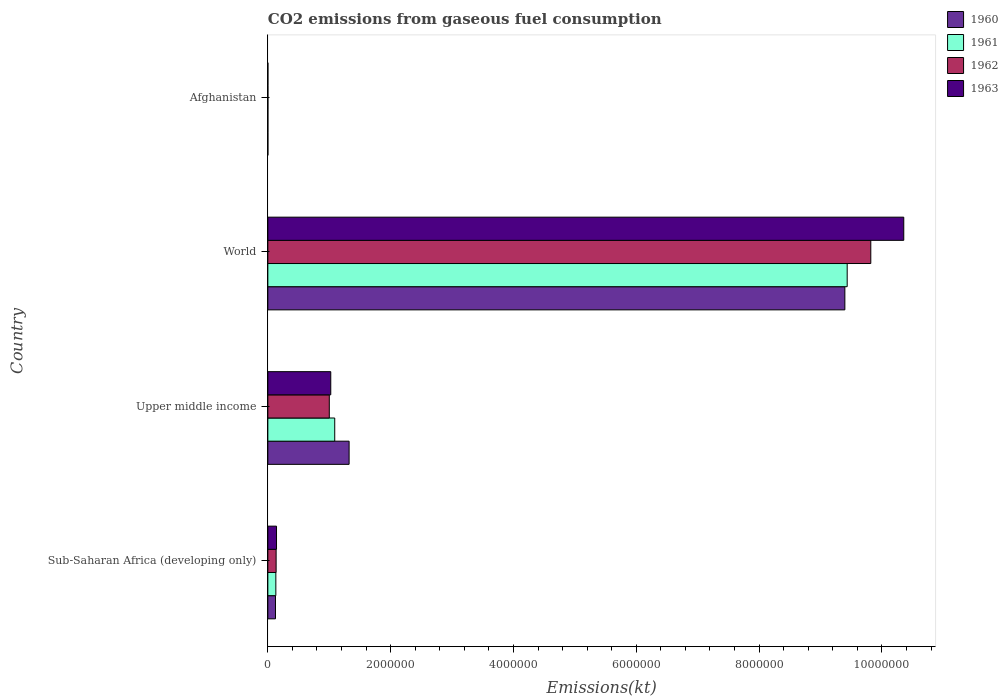How many different coloured bars are there?
Keep it short and to the point. 4. How many groups of bars are there?
Your answer should be compact. 4. Are the number of bars per tick equal to the number of legend labels?
Ensure brevity in your answer.  Yes. What is the label of the 3rd group of bars from the top?
Give a very brief answer. Upper middle income. What is the amount of CO2 emitted in 1960 in Sub-Saharan Africa (developing only)?
Your answer should be very brief. 1.24e+05. Across all countries, what is the maximum amount of CO2 emitted in 1961?
Offer a terse response. 9.43e+06. Across all countries, what is the minimum amount of CO2 emitted in 1962?
Keep it short and to the point. 689.4. In which country was the amount of CO2 emitted in 1961 minimum?
Your response must be concise. Afghanistan. What is the total amount of CO2 emitted in 1960 in the graph?
Your response must be concise. 1.08e+07. What is the difference between the amount of CO2 emitted in 1962 in Sub-Saharan Africa (developing only) and that in World?
Your answer should be very brief. -9.68e+06. What is the difference between the amount of CO2 emitted in 1961 in Afghanistan and the amount of CO2 emitted in 1960 in Upper middle income?
Your answer should be compact. -1.32e+06. What is the average amount of CO2 emitted in 1963 per country?
Your answer should be very brief. 2.88e+06. What is the difference between the amount of CO2 emitted in 1961 and amount of CO2 emitted in 1960 in Upper middle income?
Your response must be concise. -2.34e+05. In how many countries, is the amount of CO2 emitted in 1962 greater than 2000000 kt?
Give a very brief answer. 1. What is the ratio of the amount of CO2 emitted in 1961 in Sub-Saharan Africa (developing only) to that in World?
Keep it short and to the point. 0.01. What is the difference between the highest and the second highest amount of CO2 emitted in 1961?
Make the answer very short. 8.35e+06. What is the difference between the highest and the lowest amount of CO2 emitted in 1963?
Your answer should be very brief. 1.04e+07. What does the 2nd bar from the bottom in Upper middle income represents?
Offer a terse response. 1961. Are the values on the major ticks of X-axis written in scientific E-notation?
Your response must be concise. No. Does the graph contain grids?
Give a very brief answer. No. Where does the legend appear in the graph?
Keep it short and to the point. Top right. What is the title of the graph?
Your answer should be very brief. CO2 emissions from gaseous fuel consumption. Does "2015" appear as one of the legend labels in the graph?
Provide a succinct answer. No. What is the label or title of the X-axis?
Provide a succinct answer. Emissions(kt). What is the label or title of the Y-axis?
Give a very brief answer. Country. What is the Emissions(kt) of 1960 in Sub-Saharan Africa (developing only)?
Ensure brevity in your answer.  1.24e+05. What is the Emissions(kt) of 1961 in Sub-Saharan Africa (developing only)?
Offer a terse response. 1.30e+05. What is the Emissions(kt) in 1962 in Sub-Saharan Africa (developing only)?
Give a very brief answer. 1.35e+05. What is the Emissions(kt) in 1963 in Sub-Saharan Africa (developing only)?
Offer a terse response. 1.41e+05. What is the Emissions(kt) in 1960 in Upper middle income?
Your answer should be very brief. 1.32e+06. What is the Emissions(kt) in 1961 in Upper middle income?
Offer a very short reply. 1.09e+06. What is the Emissions(kt) of 1962 in Upper middle income?
Offer a terse response. 1.00e+06. What is the Emissions(kt) in 1963 in Upper middle income?
Give a very brief answer. 1.02e+06. What is the Emissions(kt) in 1960 in World?
Your response must be concise. 9.40e+06. What is the Emissions(kt) of 1961 in World?
Keep it short and to the point. 9.43e+06. What is the Emissions(kt) of 1962 in World?
Provide a short and direct response. 9.82e+06. What is the Emissions(kt) of 1963 in World?
Provide a succinct answer. 1.04e+07. What is the Emissions(kt) of 1960 in Afghanistan?
Provide a succinct answer. 414.37. What is the Emissions(kt) in 1961 in Afghanistan?
Provide a succinct answer. 491.38. What is the Emissions(kt) in 1962 in Afghanistan?
Your answer should be compact. 689.4. What is the Emissions(kt) of 1963 in Afghanistan?
Keep it short and to the point. 707.73. Across all countries, what is the maximum Emissions(kt) in 1960?
Make the answer very short. 9.40e+06. Across all countries, what is the maximum Emissions(kt) of 1961?
Offer a terse response. 9.43e+06. Across all countries, what is the maximum Emissions(kt) in 1962?
Offer a terse response. 9.82e+06. Across all countries, what is the maximum Emissions(kt) of 1963?
Ensure brevity in your answer.  1.04e+07. Across all countries, what is the minimum Emissions(kt) of 1960?
Offer a terse response. 414.37. Across all countries, what is the minimum Emissions(kt) of 1961?
Keep it short and to the point. 491.38. Across all countries, what is the minimum Emissions(kt) of 1962?
Your answer should be compact. 689.4. Across all countries, what is the minimum Emissions(kt) in 1963?
Ensure brevity in your answer.  707.73. What is the total Emissions(kt) of 1960 in the graph?
Your answer should be very brief. 1.08e+07. What is the total Emissions(kt) in 1961 in the graph?
Provide a short and direct response. 1.07e+07. What is the total Emissions(kt) in 1962 in the graph?
Your response must be concise. 1.10e+07. What is the total Emissions(kt) in 1963 in the graph?
Provide a short and direct response. 1.15e+07. What is the difference between the Emissions(kt) in 1960 in Sub-Saharan Africa (developing only) and that in Upper middle income?
Ensure brevity in your answer.  -1.20e+06. What is the difference between the Emissions(kt) of 1961 in Sub-Saharan Africa (developing only) and that in Upper middle income?
Offer a terse response. -9.59e+05. What is the difference between the Emissions(kt) of 1962 in Sub-Saharan Africa (developing only) and that in Upper middle income?
Your response must be concise. -8.66e+05. What is the difference between the Emissions(kt) of 1963 in Sub-Saharan Africa (developing only) and that in Upper middle income?
Ensure brevity in your answer.  -8.83e+05. What is the difference between the Emissions(kt) of 1960 in Sub-Saharan Africa (developing only) and that in World?
Offer a terse response. -9.27e+06. What is the difference between the Emissions(kt) in 1961 in Sub-Saharan Africa (developing only) and that in World?
Offer a very short reply. -9.30e+06. What is the difference between the Emissions(kt) of 1962 in Sub-Saharan Africa (developing only) and that in World?
Make the answer very short. -9.68e+06. What is the difference between the Emissions(kt) of 1963 in Sub-Saharan Africa (developing only) and that in World?
Give a very brief answer. -1.02e+07. What is the difference between the Emissions(kt) in 1960 in Sub-Saharan Africa (developing only) and that in Afghanistan?
Provide a short and direct response. 1.24e+05. What is the difference between the Emissions(kt) in 1961 in Sub-Saharan Africa (developing only) and that in Afghanistan?
Provide a short and direct response. 1.30e+05. What is the difference between the Emissions(kt) in 1962 in Sub-Saharan Africa (developing only) and that in Afghanistan?
Offer a terse response. 1.34e+05. What is the difference between the Emissions(kt) in 1963 in Sub-Saharan Africa (developing only) and that in Afghanistan?
Your response must be concise. 1.41e+05. What is the difference between the Emissions(kt) of 1960 in Upper middle income and that in World?
Give a very brief answer. -8.07e+06. What is the difference between the Emissions(kt) of 1961 in Upper middle income and that in World?
Provide a short and direct response. -8.35e+06. What is the difference between the Emissions(kt) of 1962 in Upper middle income and that in World?
Your answer should be very brief. -8.82e+06. What is the difference between the Emissions(kt) of 1963 in Upper middle income and that in World?
Offer a terse response. -9.33e+06. What is the difference between the Emissions(kt) in 1960 in Upper middle income and that in Afghanistan?
Offer a terse response. 1.32e+06. What is the difference between the Emissions(kt) of 1961 in Upper middle income and that in Afghanistan?
Your answer should be compact. 1.09e+06. What is the difference between the Emissions(kt) of 1962 in Upper middle income and that in Afghanistan?
Offer a terse response. 1.00e+06. What is the difference between the Emissions(kt) in 1963 in Upper middle income and that in Afghanistan?
Give a very brief answer. 1.02e+06. What is the difference between the Emissions(kt) in 1960 in World and that in Afghanistan?
Ensure brevity in your answer.  9.40e+06. What is the difference between the Emissions(kt) of 1961 in World and that in Afghanistan?
Your answer should be very brief. 9.43e+06. What is the difference between the Emissions(kt) of 1962 in World and that in Afghanistan?
Offer a very short reply. 9.82e+06. What is the difference between the Emissions(kt) of 1963 in World and that in Afghanistan?
Keep it short and to the point. 1.04e+07. What is the difference between the Emissions(kt) in 1960 in Sub-Saharan Africa (developing only) and the Emissions(kt) in 1961 in Upper middle income?
Your answer should be compact. -9.65e+05. What is the difference between the Emissions(kt) of 1960 in Sub-Saharan Africa (developing only) and the Emissions(kt) of 1962 in Upper middle income?
Offer a terse response. -8.76e+05. What is the difference between the Emissions(kt) in 1960 in Sub-Saharan Africa (developing only) and the Emissions(kt) in 1963 in Upper middle income?
Offer a terse response. -9.00e+05. What is the difference between the Emissions(kt) of 1961 in Sub-Saharan Africa (developing only) and the Emissions(kt) of 1962 in Upper middle income?
Offer a terse response. -8.71e+05. What is the difference between the Emissions(kt) of 1961 in Sub-Saharan Africa (developing only) and the Emissions(kt) of 1963 in Upper middle income?
Provide a short and direct response. -8.94e+05. What is the difference between the Emissions(kt) of 1962 in Sub-Saharan Africa (developing only) and the Emissions(kt) of 1963 in Upper middle income?
Provide a short and direct response. -8.90e+05. What is the difference between the Emissions(kt) of 1960 in Sub-Saharan Africa (developing only) and the Emissions(kt) of 1961 in World?
Your answer should be compact. -9.31e+06. What is the difference between the Emissions(kt) in 1960 in Sub-Saharan Africa (developing only) and the Emissions(kt) in 1962 in World?
Keep it short and to the point. -9.69e+06. What is the difference between the Emissions(kt) in 1960 in Sub-Saharan Africa (developing only) and the Emissions(kt) in 1963 in World?
Your answer should be compact. -1.02e+07. What is the difference between the Emissions(kt) in 1961 in Sub-Saharan Africa (developing only) and the Emissions(kt) in 1962 in World?
Your response must be concise. -9.69e+06. What is the difference between the Emissions(kt) in 1961 in Sub-Saharan Africa (developing only) and the Emissions(kt) in 1963 in World?
Your answer should be very brief. -1.02e+07. What is the difference between the Emissions(kt) of 1962 in Sub-Saharan Africa (developing only) and the Emissions(kt) of 1963 in World?
Keep it short and to the point. -1.02e+07. What is the difference between the Emissions(kt) of 1960 in Sub-Saharan Africa (developing only) and the Emissions(kt) of 1961 in Afghanistan?
Provide a short and direct response. 1.24e+05. What is the difference between the Emissions(kt) in 1960 in Sub-Saharan Africa (developing only) and the Emissions(kt) in 1962 in Afghanistan?
Provide a succinct answer. 1.24e+05. What is the difference between the Emissions(kt) in 1960 in Sub-Saharan Africa (developing only) and the Emissions(kt) in 1963 in Afghanistan?
Your answer should be compact. 1.24e+05. What is the difference between the Emissions(kt) of 1961 in Sub-Saharan Africa (developing only) and the Emissions(kt) of 1962 in Afghanistan?
Your response must be concise. 1.30e+05. What is the difference between the Emissions(kt) of 1961 in Sub-Saharan Africa (developing only) and the Emissions(kt) of 1963 in Afghanistan?
Keep it short and to the point. 1.29e+05. What is the difference between the Emissions(kt) in 1962 in Sub-Saharan Africa (developing only) and the Emissions(kt) in 1963 in Afghanistan?
Give a very brief answer. 1.34e+05. What is the difference between the Emissions(kt) of 1960 in Upper middle income and the Emissions(kt) of 1961 in World?
Your answer should be compact. -8.11e+06. What is the difference between the Emissions(kt) of 1960 in Upper middle income and the Emissions(kt) of 1962 in World?
Your answer should be compact. -8.50e+06. What is the difference between the Emissions(kt) of 1960 in Upper middle income and the Emissions(kt) of 1963 in World?
Offer a very short reply. -9.03e+06. What is the difference between the Emissions(kt) of 1961 in Upper middle income and the Emissions(kt) of 1962 in World?
Your answer should be very brief. -8.73e+06. What is the difference between the Emissions(kt) of 1961 in Upper middle income and the Emissions(kt) of 1963 in World?
Ensure brevity in your answer.  -9.27e+06. What is the difference between the Emissions(kt) of 1962 in Upper middle income and the Emissions(kt) of 1963 in World?
Ensure brevity in your answer.  -9.35e+06. What is the difference between the Emissions(kt) in 1960 in Upper middle income and the Emissions(kt) in 1961 in Afghanistan?
Your answer should be very brief. 1.32e+06. What is the difference between the Emissions(kt) of 1960 in Upper middle income and the Emissions(kt) of 1962 in Afghanistan?
Your answer should be compact. 1.32e+06. What is the difference between the Emissions(kt) of 1960 in Upper middle income and the Emissions(kt) of 1963 in Afghanistan?
Ensure brevity in your answer.  1.32e+06. What is the difference between the Emissions(kt) of 1961 in Upper middle income and the Emissions(kt) of 1962 in Afghanistan?
Your answer should be compact. 1.09e+06. What is the difference between the Emissions(kt) of 1961 in Upper middle income and the Emissions(kt) of 1963 in Afghanistan?
Ensure brevity in your answer.  1.09e+06. What is the difference between the Emissions(kt) in 1962 in Upper middle income and the Emissions(kt) in 1963 in Afghanistan?
Make the answer very short. 1.00e+06. What is the difference between the Emissions(kt) in 1960 in World and the Emissions(kt) in 1961 in Afghanistan?
Give a very brief answer. 9.40e+06. What is the difference between the Emissions(kt) of 1960 in World and the Emissions(kt) of 1962 in Afghanistan?
Keep it short and to the point. 9.40e+06. What is the difference between the Emissions(kt) in 1960 in World and the Emissions(kt) in 1963 in Afghanistan?
Provide a short and direct response. 9.40e+06. What is the difference between the Emissions(kt) of 1961 in World and the Emissions(kt) of 1962 in Afghanistan?
Your answer should be very brief. 9.43e+06. What is the difference between the Emissions(kt) of 1961 in World and the Emissions(kt) of 1963 in Afghanistan?
Provide a succinct answer. 9.43e+06. What is the difference between the Emissions(kt) of 1962 in World and the Emissions(kt) of 1963 in Afghanistan?
Your answer should be compact. 9.82e+06. What is the average Emissions(kt) of 1960 per country?
Your response must be concise. 2.71e+06. What is the average Emissions(kt) of 1961 per country?
Your answer should be very brief. 2.66e+06. What is the average Emissions(kt) of 1962 per country?
Offer a very short reply. 2.74e+06. What is the average Emissions(kt) in 1963 per country?
Ensure brevity in your answer.  2.88e+06. What is the difference between the Emissions(kt) of 1960 and Emissions(kt) of 1961 in Sub-Saharan Africa (developing only)?
Your answer should be compact. -5719.01. What is the difference between the Emissions(kt) of 1960 and Emissions(kt) of 1962 in Sub-Saharan Africa (developing only)?
Provide a succinct answer. -1.03e+04. What is the difference between the Emissions(kt) in 1960 and Emissions(kt) in 1963 in Sub-Saharan Africa (developing only)?
Provide a succinct answer. -1.68e+04. What is the difference between the Emissions(kt) of 1961 and Emissions(kt) of 1962 in Sub-Saharan Africa (developing only)?
Make the answer very short. -4566.81. What is the difference between the Emissions(kt) in 1961 and Emissions(kt) in 1963 in Sub-Saharan Africa (developing only)?
Provide a short and direct response. -1.11e+04. What is the difference between the Emissions(kt) of 1962 and Emissions(kt) of 1963 in Sub-Saharan Africa (developing only)?
Offer a very short reply. -6516.22. What is the difference between the Emissions(kt) in 1960 and Emissions(kt) in 1961 in Upper middle income?
Keep it short and to the point. 2.34e+05. What is the difference between the Emissions(kt) of 1960 and Emissions(kt) of 1962 in Upper middle income?
Offer a very short reply. 3.23e+05. What is the difference between the Emissions(kt) in 1960 and Emissions(kt) in 1963 in Upper middle income?
Offer a very short reply. 2.99e+05. What is the difference between the Emissions(kt) of 1961 and Emissions(kt) of 1962 in Upper middle income?
Offer a terse response. 8.85e+04. What is the difference between the Emissions(kt) of 1961 and Emissions(kt) of 1963 in Upper middle income?
Ensure brevity in your answer.  6.47e+04. What is the difference between the Emissions(kt) of 1962 and Emissions(kt) of 1963 in Upper middle income?
Make the answer very short. -2.38e+04. What is the difference between the Emissions(kt) of 1960 and Emissions(kt) of 1961 in World?
Keep it short and to the point. -3.77e+04. What is the difference between the Emissions(kt) in 1960 and Emissions(kt) in 1962 in World?
Ensure brevity in your answer.  -4.22e+05. What is the difference between the Emissions(kt) in 1960 and Emissions(kt) in 1963 in World?
Keep it short and to the point. -9.59e+05. What is the difference between the Emissions(kt) in 1961 and Emissions(kt) in 1962 in World?
Give a very brief answer. -3.84e+05. What is the difference between the Emissions(kt) of 1961 and Emissions(kt) of 1963 in World?
Offer a very short reply. -9.21e+05. What is the difference between the Emissions(kt) of 1962 and Emissions(kt) of 1963 in World?
Your answer should be very brief. -5.37e+05. What is the difference between the Emissions(kt) of 1960 and Emissions(kt) of 1961 in Afghanistan?
Offer a terse response. -77.01. What is the difference between the Emissions(kt) of 1960 and Emissions(kt) of 1962 in Afghanistan?
Keep it short and to the point. -275.02. What is the difference between the Emissions(kt) in 1960 and Emissions(kt) in 1963 in Afghanistan?
Make the answer very short. -293.36. What is the difference between the Emissions(kt) of 1961 and Emissions(kt) of 1962 in Afghanistan?
Give a very brief answer. -198.02. What is the difference between the Emissions(kt) of 1961 and Emissions(kt) of 1963 in Afghanistan?
Make the answer very short. -216.35. What is the difference between the Emissions(kt) of 1962 and Emissions(kt) of 1963 in Afghanistan?
Offer a terse response. -18.34. What is the ratio of the Emissions(kt) in 1960 in Sub-Saharan Africa (developing only) to that in Upper middle income?
Your answer should be very brief. 0.09. What is the ratio of the Emissions(kt) of 1961 in Sub-Saharan Africa (developing only) to that in Upper middle income?
Your response must be concise. 0.12. What is the ratio of the Emissions(kt) in 1962 in Sub-Saharan Africa (developing only) to that in Upper middle income?
Make the answer very short. 0.13. What is the ratio of the Emissions(kt) in 1963 in Sub-Saharan Africa (developing only) to that in Upper middle income?
Your response must be concise. 0.14. What is the ratio of the Emissions(kt) in 1960 in Sub-Saharan Africa (developing only) to that in World?
Your response must be concise. 0.01. What is the ratio of the Emissions(kt) of 1961 in Sub-Saharan Africa (developing only) to that in World?
Ensure brevity in your answer.  0.01. What is the ratio of the Emissions(kt) of 1962 in Sub-Saharan Africa (developing only) to that in World?
Your answer should be compact. 0.01. What is the ratio of the Emissions(kt) of 1963 in Sub-Saharan Africa (developing only) to that in World?
Provide a short and direct response. 0.01. What is the ratio of the Emissions(kt) of 1960 in Sub-Saharan Africa (developing only) to that in Afghanistan?
Offer a very short reply. 300.4. What is the ratio of the Emissions(kt) in 1961 in Sub-Saharan Africa (developing only) to that in Afghanistan?
Ensure brevity in your answer.  264.96. What is the ratio of the Emissions(kt) of 1962 in Sub-Saharan Africa (developing only) to that in Afghanistan?
Ensure brevity in your answer.  195.48. What is the ratio of the Emissions(kt) in 1963 in Sub-Saharan Africa (developing only) to that in Afghanistan?
Your response must be concise. 199.62. What is the ratio of the Emissions(kt) of 1960 in Upper middle income to that in World?
Your answer should be compact. 0.14. What is the ratio of the Emissions(kt) of 1961 in Upper middle income to that in World?
Ensure brevity in your answer.  0.12. What is the ratio of the Emissions(kt) of 1962 in Upper middle income to that in World?
Your answer should be compact. 0.1. What is the ratio of the Emissions(kt) in 1963 in Upper middle income to that in World?
Provide a succinct answer. 0.1. What is the ratio of the Emissions(kt) of 1960 in Upper middle income to that in Afghanistan?
Make the answer very short. 3193.73. What is the ratio of the Emissions(kt) of 1961 in Upper middle income to that in Afghanistan?
Provide a succinct answer. 2216.93. What is the ratio of the Emissions(kt) of 1962 in Upper middle income to that in Afghanistan?
Keep it short and to the point. 1451.8. What is the ratio of the Emissions(kt) in 1963 in Upper middle income to that in Afghanistan?
Provide a succinct answer. 1447.78. What is the ratio of the Emissions(kt) of 1960 in World to that in Afghanistan?
Your answer should be very brief. 2.27e+04. What is the ratio of the Emissions(kt) of 1961 in World to that in Afghanistan?
Provide a succinct answer. 1.92e+04. What is the ratio of the Emissions(kt) in 1962 in World to that in Afghanistan?
Your answer should be very brief. 1.42e+04. What is the ratio of the Emissions(kt) of 1963 in World to that in Afghanistan?
Provide a short and direct response. 1.46e+04. What is the difference between the highest and the second highest Emissions(kt) of 1960?
Make the answer very short. 8.07e+06. What is the difference between the highest and the second highest Emissions(kt) in 1961?
Your response must be concise. 8.35e+06. What is the difference between the highest and the second highest Emissions(kt) in 1962?
Ensure brevity in your answer.  8.82e+06. What is the difference between the highest and the second highest Emissions(kt) of 1963?
Keep it short and to the point. 9.33e+06. What is the difference between the highest and the lowest Emissions(kt) of 1960?
Offer a very short reply. 9.40e+06. What is the difference between the highest and the lowest Emissions(kt) of 1961?
Offer a very short reply. 9.43e+06. What is the difference between the highest and the lowest Emissions(kt) of 1962?
Make the answer very short. 9.82e+06. What is the difference between the highest and the lowest Emissions(kt) in 1963?
Keep it short and to the point. 1.04e+07. 